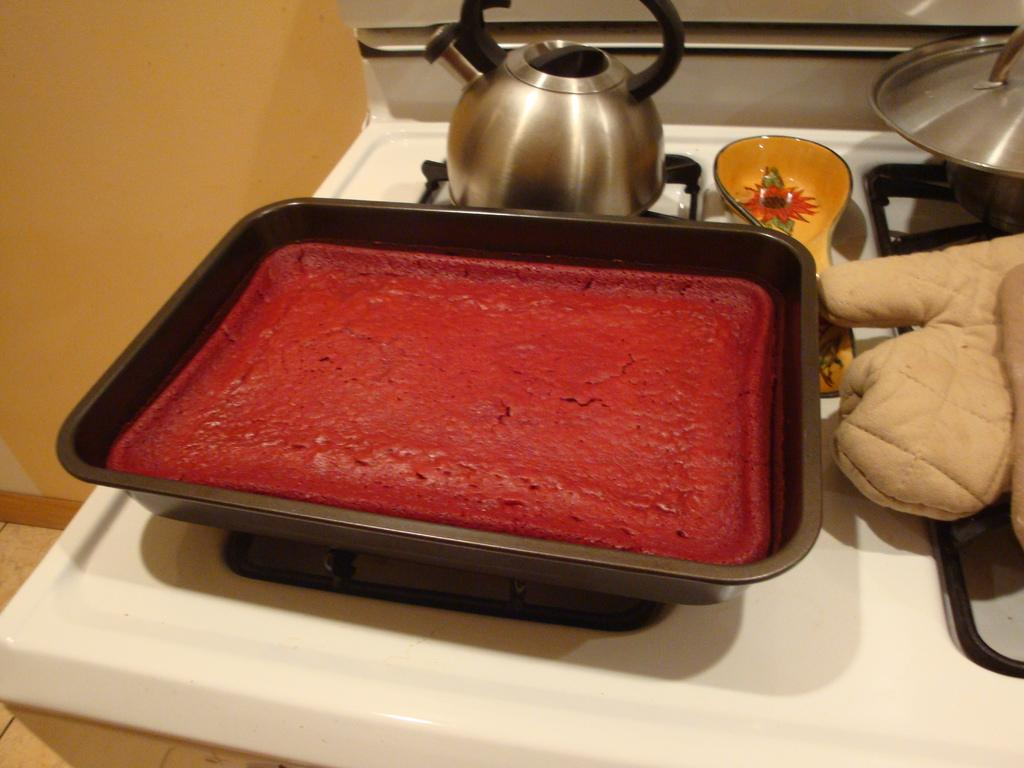What is on the table in the image? There is a baked cake in a tray and a tea kettle on the table. What can be seen behind the table? There are vessels on a stove behind the table. What is near the stove? A glove is present near the stove. What is visible in the background of the image? There is a wall visible in the background. Can you see any ghosts in the image? There are no ghosts present in the image. What type of pancake is being cooked on the stove? There is no pancake visible in the image; it features a baked cake, a tea kettle, and vessels on a stove. 